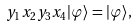Convert formula to latex. <formula><loc_0><loc_0><loc_500><loc_500>y _ { 1 } x _ { 2 } y _ { 3 } x _ { 4 } | \varphi \rangle = | \varphi \rangle ,</formula> 